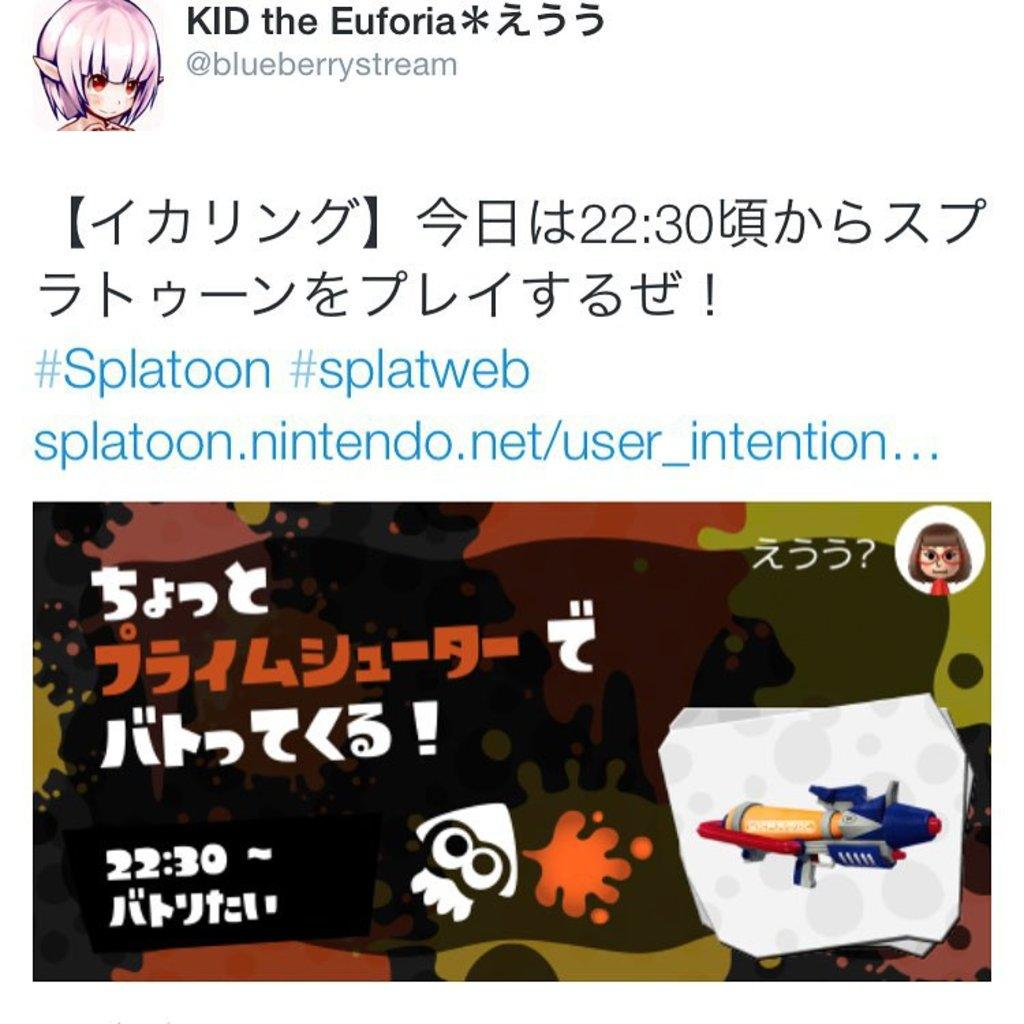What style is the image in? The image is a cartoon. What else can be seen in the image besides the cartoon picture? There is text in the image. Can you describe the main subject of the image? There is a cartoon picture in the image. What type of trousers is the cartoon character wearing in the image? There is no cartoon character present in the image, so it is not possible to determine what type of trousers they might be wearing. What hobbies does the text in the image suggest the cartoon character has? There is no cartoon character present in the image, so it is not possible to determine their hobbies based on the text. 